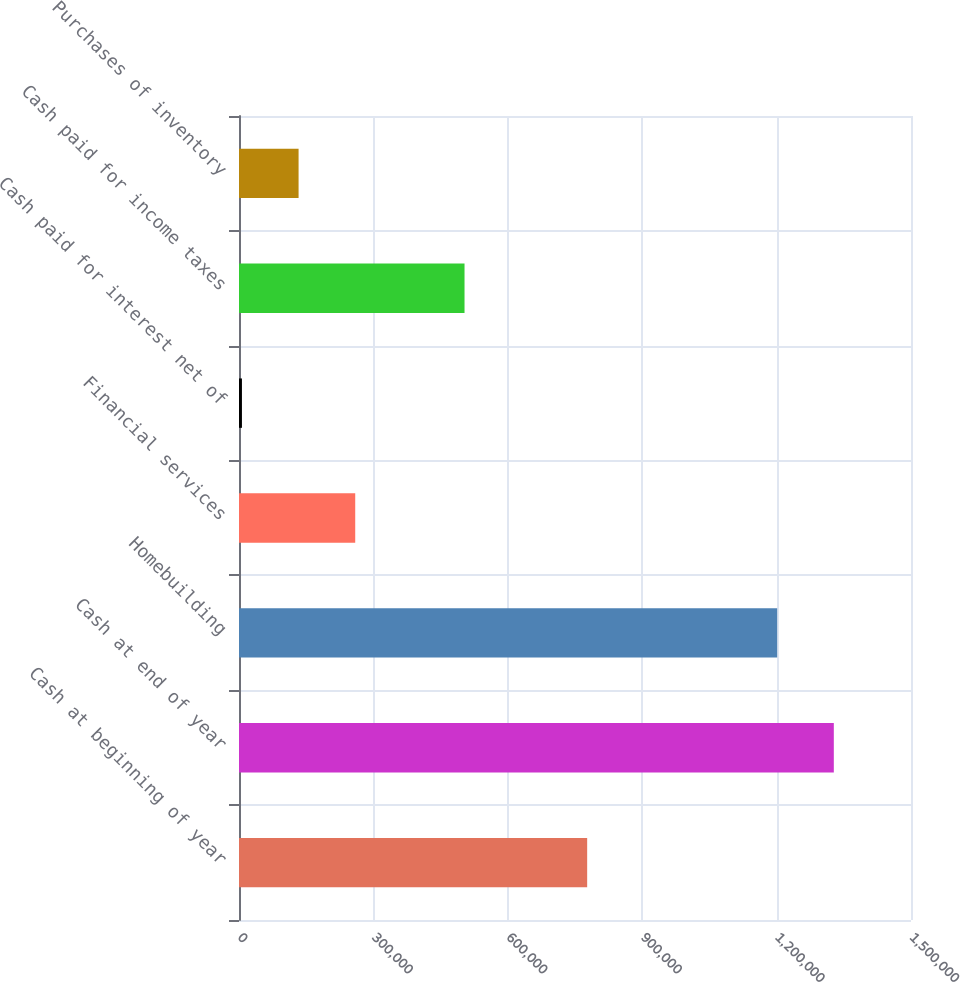Convert chart. <chart><loc_0><loc_0><loc_500><loc_500><bar_chart><fcel>Cash at beginning of year<fcel>Cash at end of year<fcel>Homebuilding<fcel>Financial services<fcel>Cash paid for interest net of<fcel>Cash paid for income taxes<fcel>Purchases of inventory<nl><fcel>777159<fcel>1.32771e+06<fcel>1.20128e+06<fcel>259422<fcel>6559<fcel>503410<fcel>132990<nl></chart> 